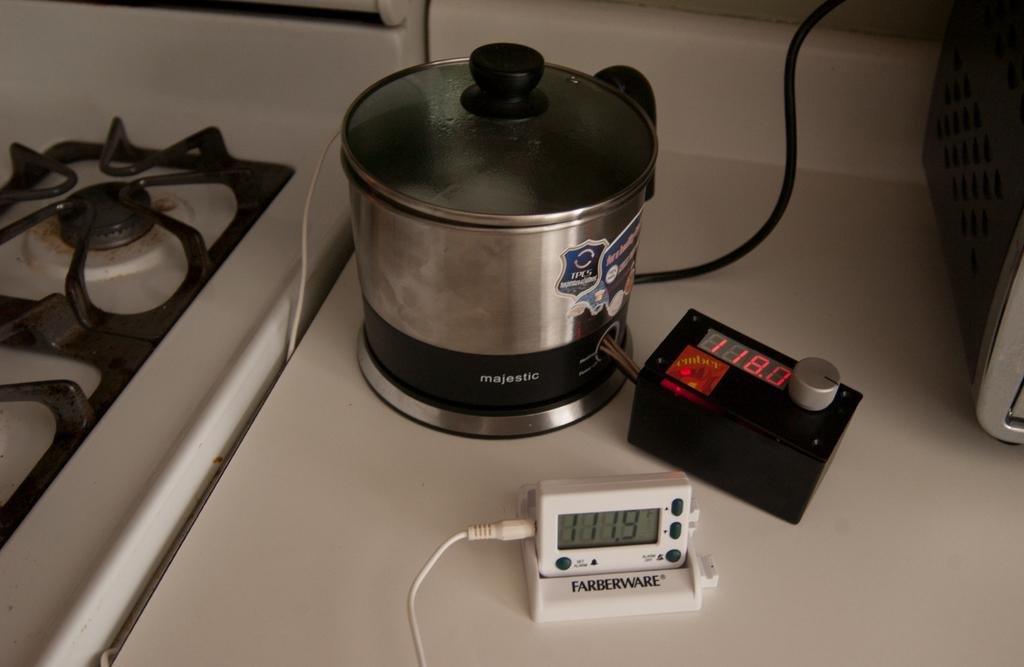<image>
Create a compact narrative representing the image presented. A Farberware food thermometer that shows 111.9 degrees Fahrenheit. 